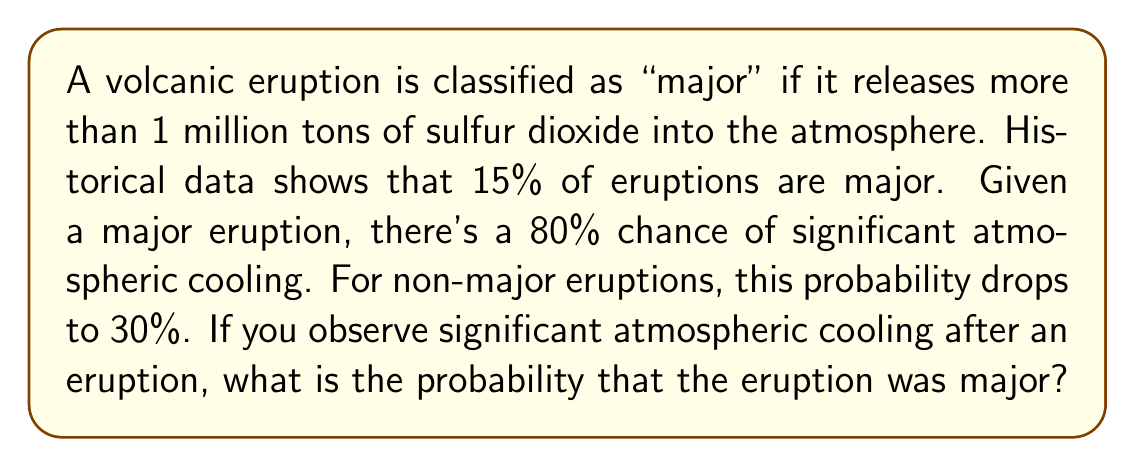Show me your answer to this math problem. To solve this problem, we'll use Bayes' theorem:

$$ P(A|B) = \frac{P(B|A) \cdot P(A)}{P(B)} $$

Where:
A: The eruption was major
B: Significant atmospheric cooling observed

Given:
$P(A) = 0.15$ (probability of a major eruption)
$P(B|A) = 0.80$ (probability of cooling given a major eruption)
$P(B|\text{not }A) = 0.30$ (probability of cooling given a non-major eruption)

Step 1: Calculate $P(B)$ using the law of total probability:
$$ P(B) = P(B|A) \cdot P(A) + P(B|\text{not }A) \cdot P(\text{not }A) $$
$$ P(B) = 0.80 \cdot 0.15 + 0.30 \cdot 0.85 = 0.12 + 0.255 = 0.375 $$

Step 2: Apply Bayes' theorem:
$$ P(A|B) = \frac{P(B|A) \cdot P(A)}{P(B)} = \frac{0.80 \cdot 0.15}{0.375} = \frac{0.12}{0.375} = 0.32 $$

Therefore, the probability that the eruption was major, given significant atmospheric cooling, is 0.32 or 32%.
Answer: $0.32$ or $32\%$ 